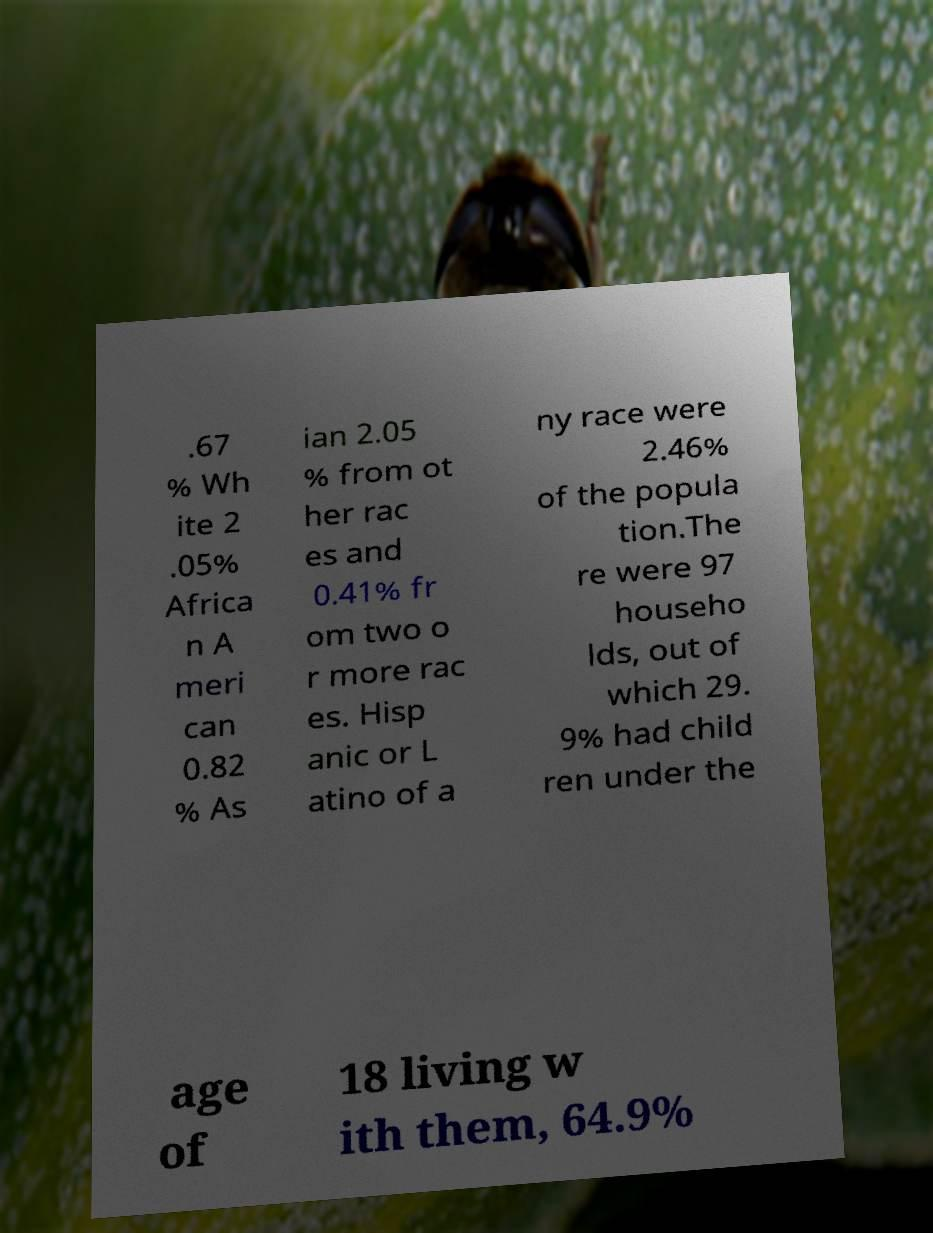Could you assist in decoding the text presented in this image and type it out clearly? .67 % Wh ite 2 .05% Africa n A meri can 0.82 % As ian 2.05 % from ot her rac es and 0.41% fr om two o r more rac es. Hisp anic or L atino of a ny race were 2.46% of the popula tion.The re were 97 househo lds, out of which 29. 9% had child ren under the age of 18 living w ith them, 64.9% 